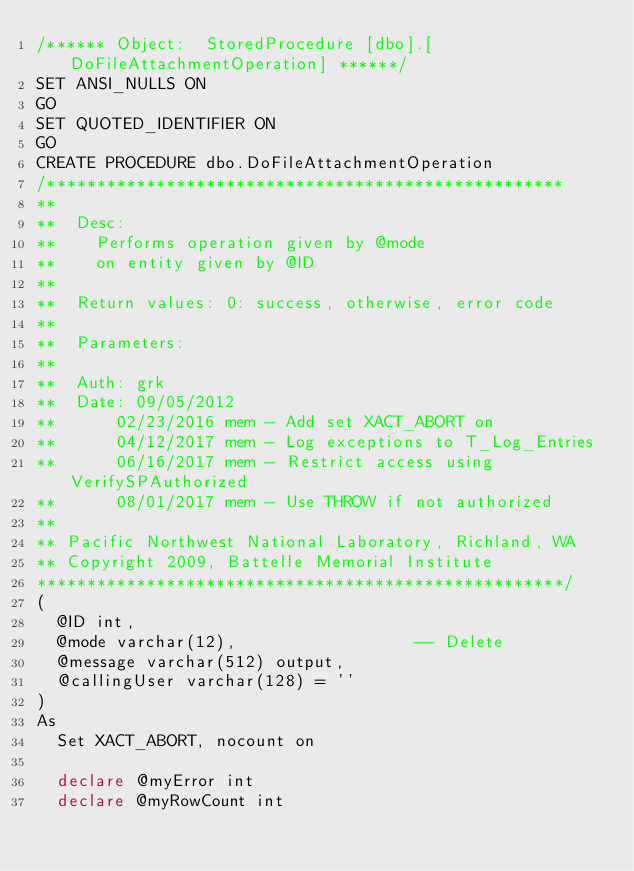Convert code to text. <code><loc_0><loc_0><loc_500><loc_500><_SQL_>/****** Object:  StoredProcedure [dbo].[DoFileAttachmentOperation] ******/
SET ANSI_NULLS ON
GO
SET QUOTED_IDENTIFIER ON
GO
CREATE PROCEDURE dbo.DoFileAttachmentOperation 
/****************************************************
**
**  Desc: 
**    Performs operation given by @mode
**    on entity given by @ID
**
**  Return values: 0: success, otherwise, error code
**
**  Parameters:
**
**  Auth:	grk
**  Date:	09/05/2012 
**			02/23/2016 mem - Add set XACT_ABORT on
**			04/12/2017 mem - Log exceptions to T_Log_Entries
**			06/16/2017 mem - Restrict access using VerifySPAuthorized
**			08/01/2017 mem - Use THROW if not authorized
**    
** Pacific Northwest National Laboratory, Richland, WA
** Copyright 2009, Battelle Memorial Institute
*****************************************************/
(
	@ID int,
	@mode varchar(12),                  -- Delete
	@message varchar(512) output,
	@callingUser varchar(128) = ''
)
As
	Set XACT_ABORT, nocount on

	declare @myError int
	declare @myRowCount int</code> 